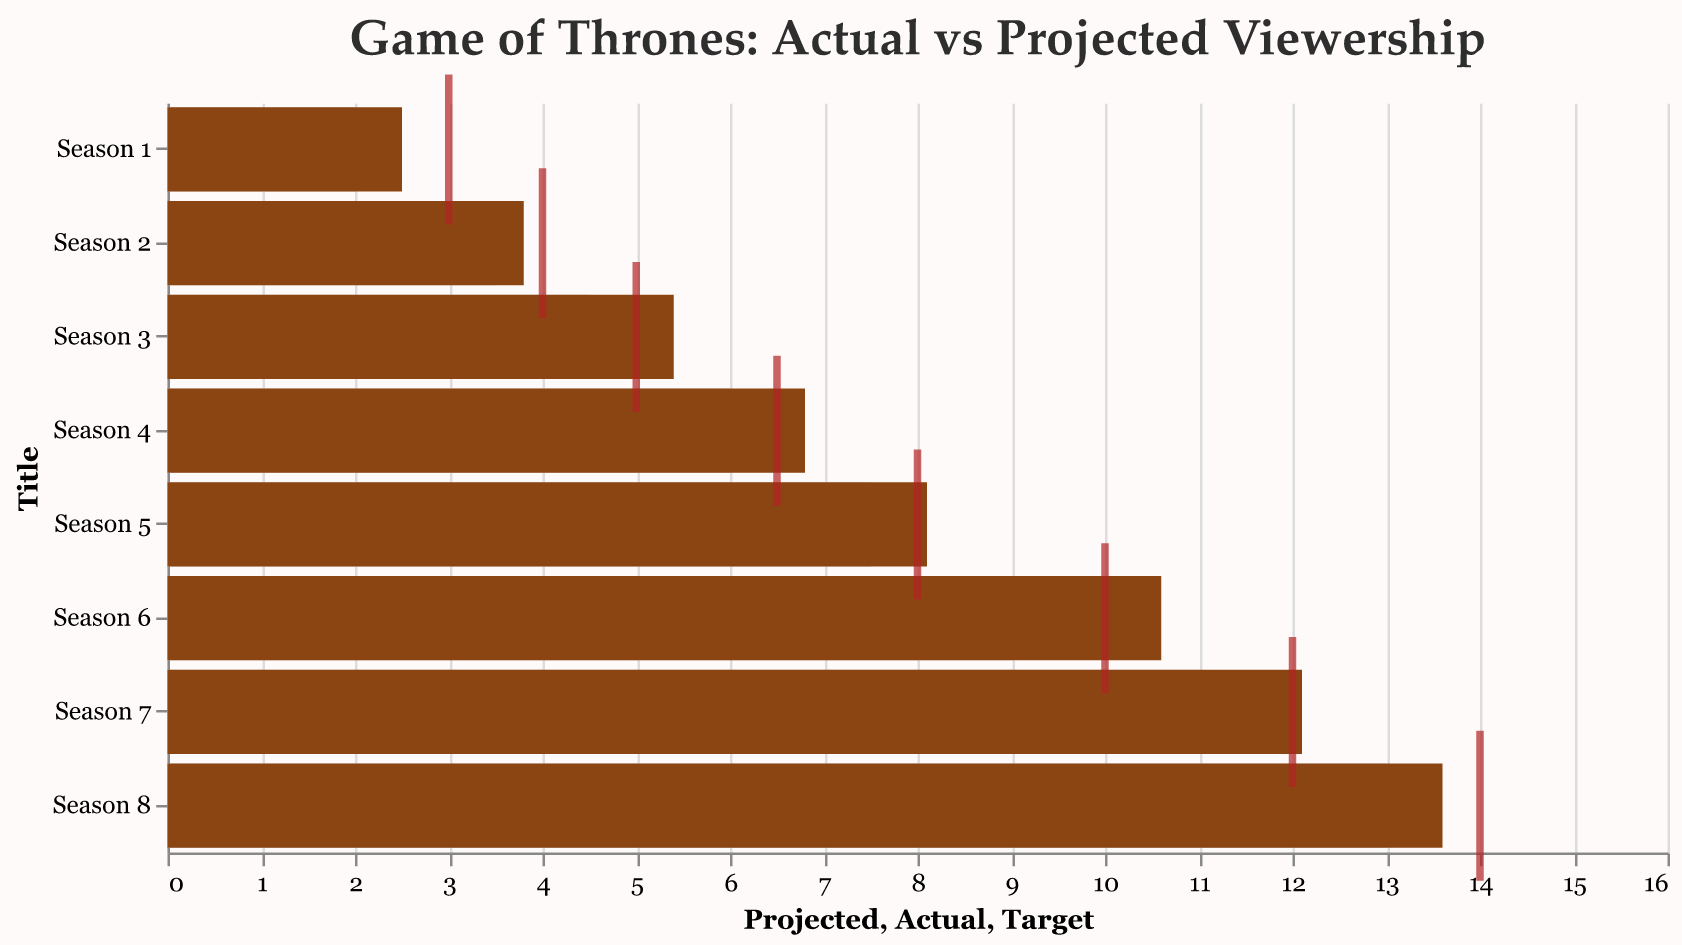what's the title of the figure? The title is displayed at the top of the figure, with larger text to indicate its importance. The title reads "Game of Thrones: Actual vs Projected Viewership".
Answer: Game of Thrones: Actual vs Projected Viewership how many seasons are shown in the figure? By counting the number of bars or tick marks along the y-axis, we can see there are eight entries, one for each season 1 through 8.
Answer: Eight what color represents the actual viewership in the figure? The figure uses color coding to differentiate between data points. The actual viewership is represented by brown bars.
Answer: Brown which season had the highest actual viewership? Looking at the bars representing the actual viewership, the longest bar corresponds to Season 8, indicating it had the highest viewership.
Answer: Season 8 what is the projected viewership for Season 4? The length of the gray bar for Season 4 represents the projected viewership, which extends to a value of 6.0.
Answer: 6.0 how does the actual viewership for Season 6 compare to its projected viewership? The actual viewership for Season 6 is represented by the brown bar, which extends to 10.6, while the gray bar for the projected viewership extends to 9.0. Thus, the actual viewership is higher than the projected viewership.
Answer: Higher what was the target viewership for Season 7, and did it meet its actual viewership? The target viewership is indicated by the red tick mark for Season 7, which is at 12.0. The actual viewership bar exceeds this target, ending at 12.1.
Answer: 12.0, Yes which season had the smallest difference between actual viewership and projected viewership? By examining the lengths of the actual and projected viewership bars and calculating their differences, Season 2 shows the least difference with 3.8 for actual and 3.5 for projected, resulting in a difference of 0.3.
Answer: Season 2 what is the average actual viewership across all seasons? Adding the actual viewership values for all seasons (2.5, 3.8, 5.4, 6.8, 8.1, 10.6, 12.1, 13.6) gives a total of 62.9. Dividing this by 8 (the number of seasons) results in an average of 7.8625.
Answer: 7.8625 how many seasons did not meet their target viewership according to the figure? By examining the length of the brown bars in comparison to the position of the red ticks, Season 1 and Season 8 are the only ones where the actual viewership did not meet or exceed the target viewership.
Answer: Two 